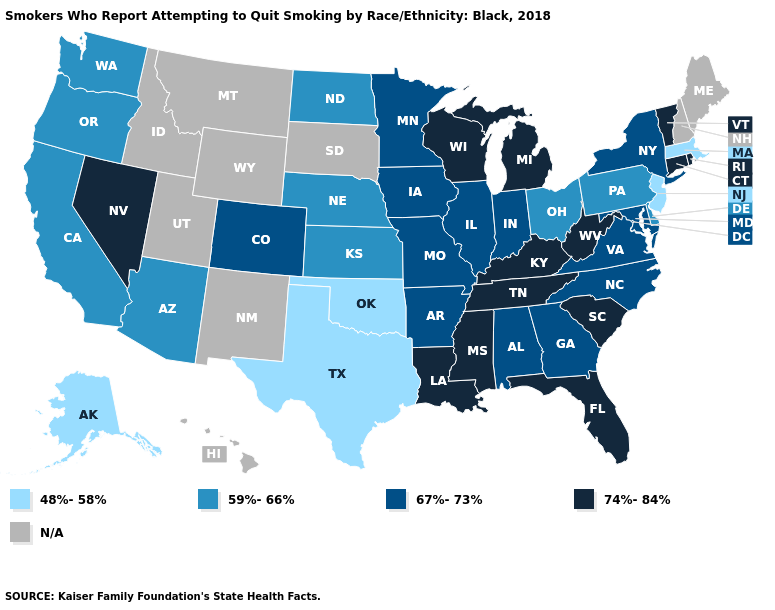Which states have the lowest value in the MidWest?
Short answer required. Kansas, Nebraska, North Dakota, Ohio. Among the states that border Delaware , does Maryland have the highest value?
Quick response, please. Yes. Among the states that border Massachusetts , does Connecticut have the highest value?
Be succinct. Yes. Name the states that have a value in the range 59%-66%?
Answer briefly. Arizona, California, Delaware, Kansas, Nebraska, North Dakota, Ohio, Oregon, Pennsylvania, Washington. Name the states that have a value in the range 59%-66%?
Keep it brief. Arizona, California, Delaware, Kansas, Nebraska, North Dakota, Ohio, Oregon, Pennsylvania, Washington. What is the lowest value in states that border Arkansas?
Give a very brief answer. 48%-58%. Does the map have missing data?
Concise answer only. Yes. Which states have the lowest value in the Northeast?
Give a very brief answer. Massachusetts, New Jersey. Name the states that have a value in the range 48%-58%?
Be succinct. Alaska, Massachusetts, New Jersey, Oklahoma, Texas. What is the value of Hawaii?
Answer briefly. N/A. What is the value of Louisiana?
Give a very brief answer. 74%-84%. Among the states that border Maryland , does Delaware have the lowest value?
Be succinct. Yes. How many symbols are there in the legend?
Quick response, please. 5. What is the value of Florida?
Be succinct. 74%-84%. 